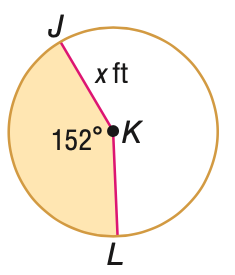Answer the mathemtical geometry problem and directly provide the correct option letter.
Question: The area A of the shaded region is given. Find x. A = 128 ft^2.
Choices: A: 4.9 B: 6.4 C: 9.8 D: 19.6 C 